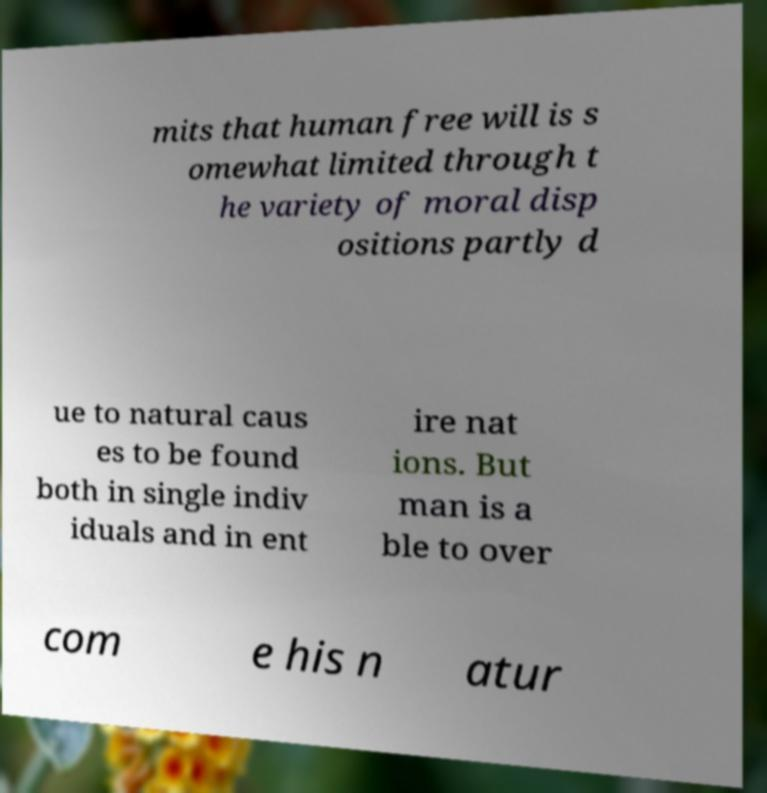There's text embedded in this image that I need extracted. Can you transcribe it verbatim? mits that human free will is s omewhat limited through t he variety of moral disp ositions partly d ue to natural caus es to be found both in single indiv iduals and in ent ire nat ions. But man is a ble to over com e his n atur 